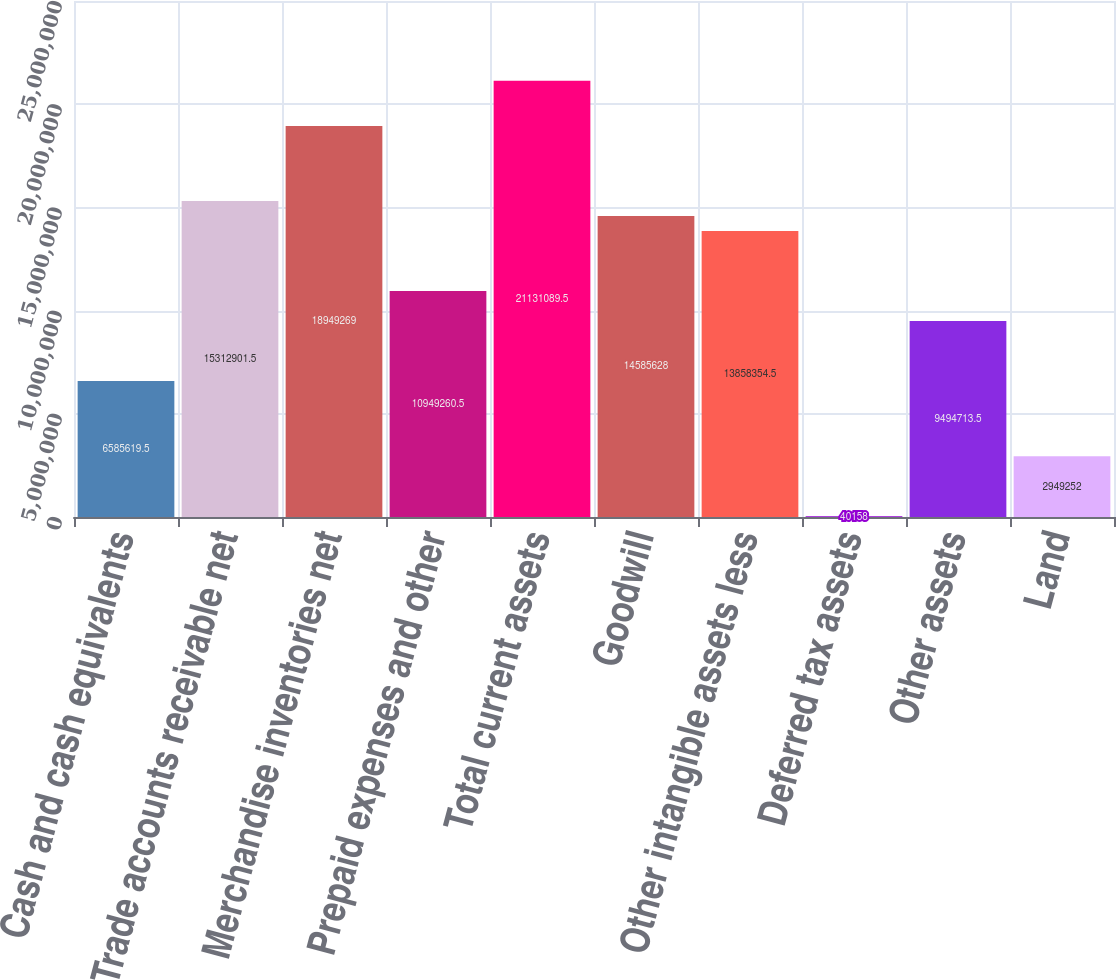Convert chart. <chart><loc_0><loc_0><loc_500><loc_500><bar_chart><fcel>Cash and cash equivalents<fcel>Trade accounts receivable net<fcel>Merchandise inventories net<fcel>Prepaid expenses and other<fcel>Total current assets<fcel>Goodwill<fcel>Other intangible assets less<fcel>Deferred tax assets<fcel>Other assets<fcel>Land<nl><fcel>6.58562e+06<fcel>1.53129e+07<fcel>1.89493e+07<fcel>1.09493e+07<fcel>2.11311e+07<fcel>1.45856e+07<fcel>1.38584e+07<fcel>40158<fcel>9.49471e+06<fcel>2.94925e+06<nl></chart> 